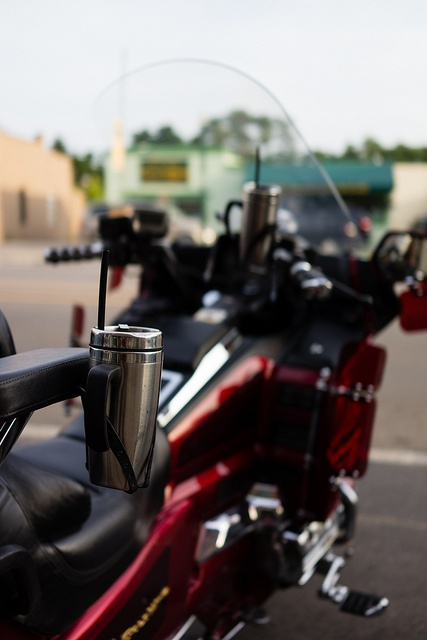Describe the objects in this image and their specific colors. I can see motorcycle in white, black, gray, lightgray, and darkgray tones, cup in white, black, and gray tones, and cup in white, black, gray, and darkgray tones in this image. 